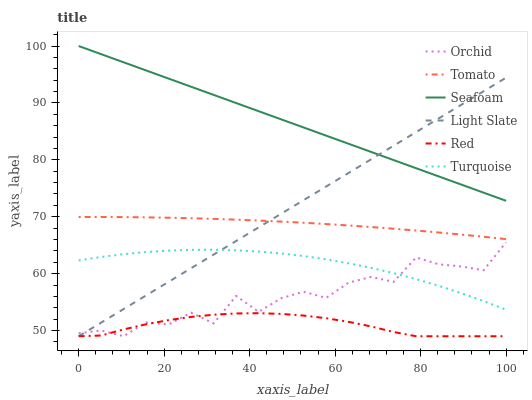Does Red have the minimum area under the curve?
Answer yes or no. Yes. Does Seafoam have the maximum area under the curve?
Answer yes or no. Yes. Does Turquoise have the minimum area under the curve?
Answer yes or no. No. Does Turquoise have the maximum area under the curve?
Answer yes or no. No. Is Light Slate the smoothest?
Answer yes or no. Yes. Is Orchid the roughest?
Answer yes or no. Yes. Is Turquoise the smoothest?
Answer yes or no. No. Is Turquoise the roughest?
Answer yes or no. No. Does Light Slate have the lowest value?
Answer yes or no. Yes. Does Turquoise have the lowest value?
Answer yes or no. No. Does Seafoam have the highest value?
Answer yes or no. Yes. Does Turquoise have the highest value?
Answer yes or no. No. Is Orchid less than Tomato?
Answer yes or no. Yes. Is Seafoam greater than Red?
Answer yes or no. Yes. Does Orchid intersect Turquoise?
Answer yes or no. Yes. Is Orchid less than Turquoise?
Answer yes or no. No. Is Orchid greater than Turquoise?
Answer yes or no. No. Does Orchid intersect Tomato?
Answer yes or no. No. 